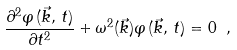Convert formula to latex. <formula><loc_0><loc_0><loc_500><loc_500>\frac { \partial ^ { 2 } \varphi \, ( \vec { k } , \, t ) } { \partial t ^ { 2 } } + \omega ^ { 2 } ( \vec { k } ) \varphi \, ( \vec { k } , \, t ) = 0 \ ,</formula> 